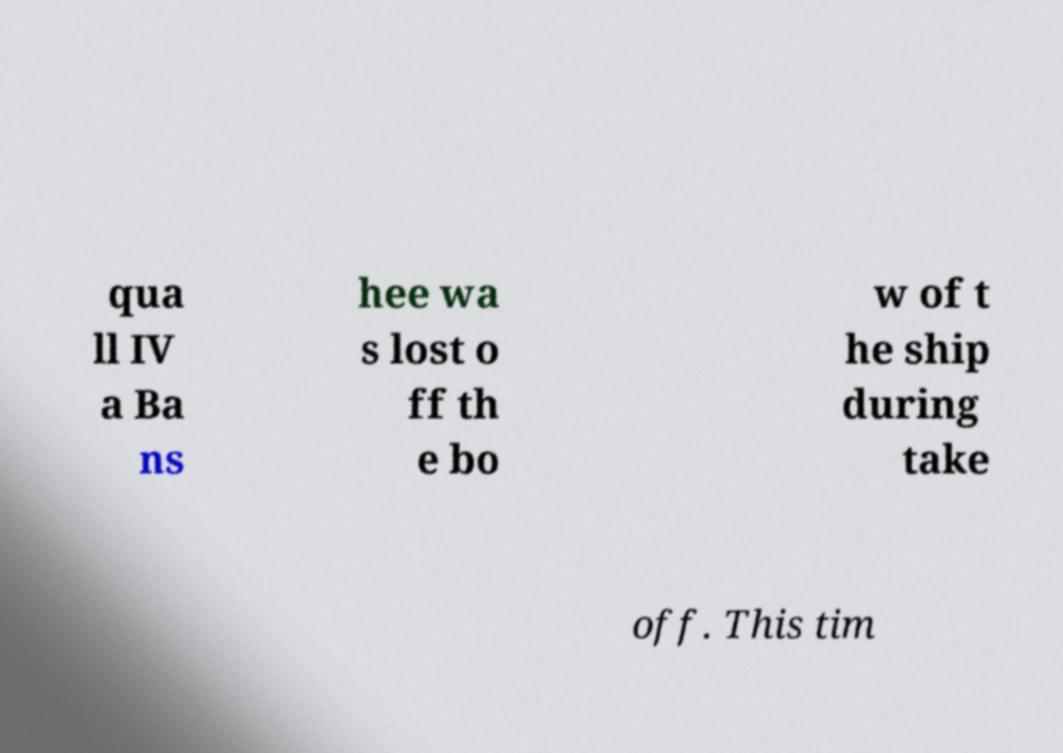Could you extract and type out the text from this image? qua ll IV a Ba ns hee wa s lost o ff th e bo w of t he ship during take off. This tim 